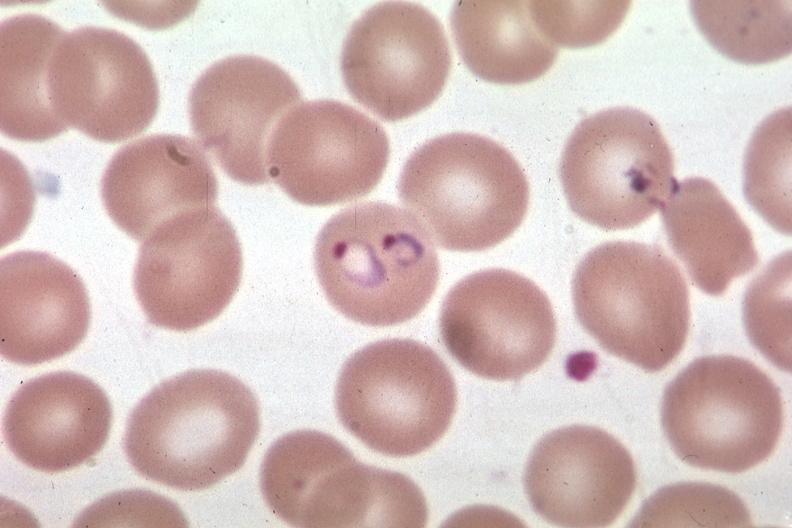what is present?
Answer the question using a single word or phrase. Blood 